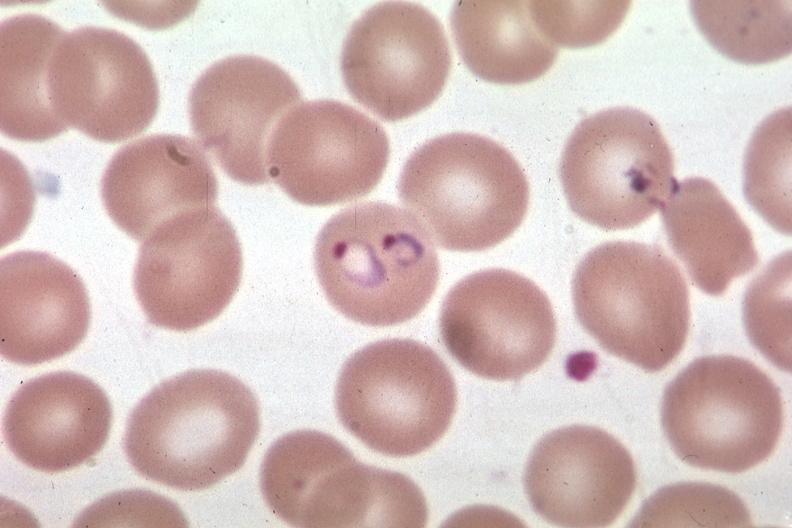what is present?
Answer the question using a single word or phrase. Blood 